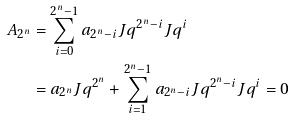<formula> <loc_0><loc_0><loc_500><loc_500>A _ { 2 ^ { n } } & = \sum _ { i = 0 } ^ { 2 ^ { n } - 1 } a _ { 2 ^ { n } - i } J q ^ { 2 ^ { n } - i } J q ^ { i } \\ & = a _ { 2 ^ { n } } J q ^ { 2 ^ { n } } + \sum _ { i = 1 } ^ { 2 ^ { n } - 1 } a _ { 2 ^ { n } - i } J q ^ { 2 ^ { n } - i } J q ^ { i } = 0</formula> 